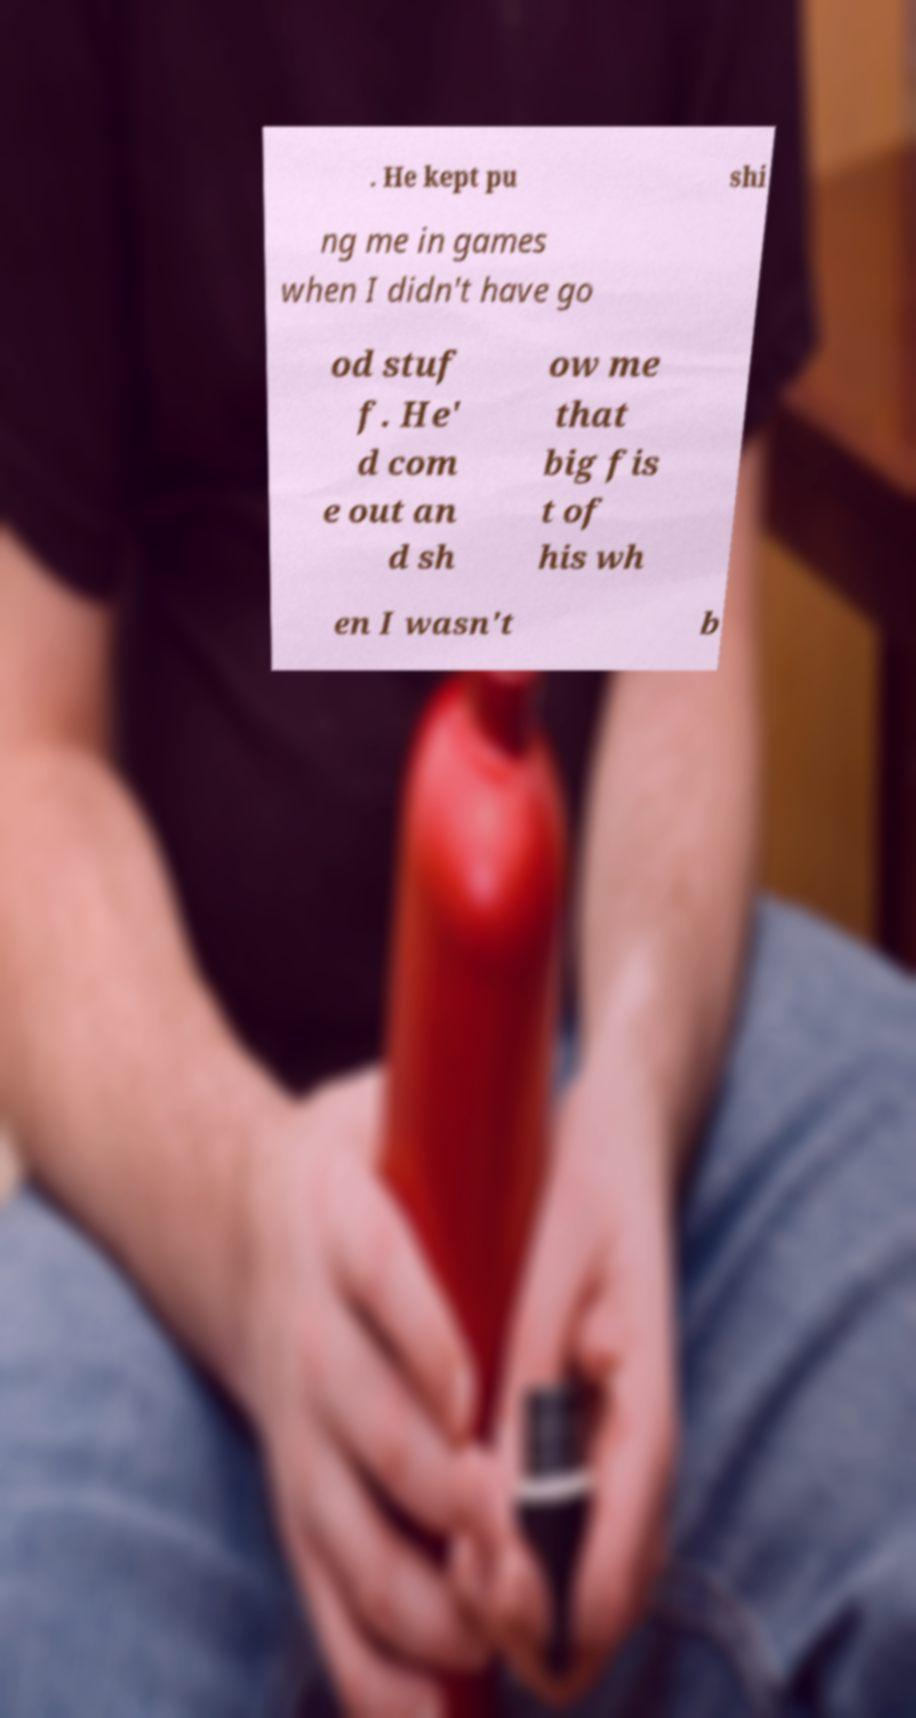Can you read and provide the text displayed in the image?This photo seems to have some interesting text. Can you extract and type it out for me? . He kept pu shi ng me in games when I didn't have go od stuf f. He' d com e out an d sh ow me that big fis t of his wh en I wasn't b 